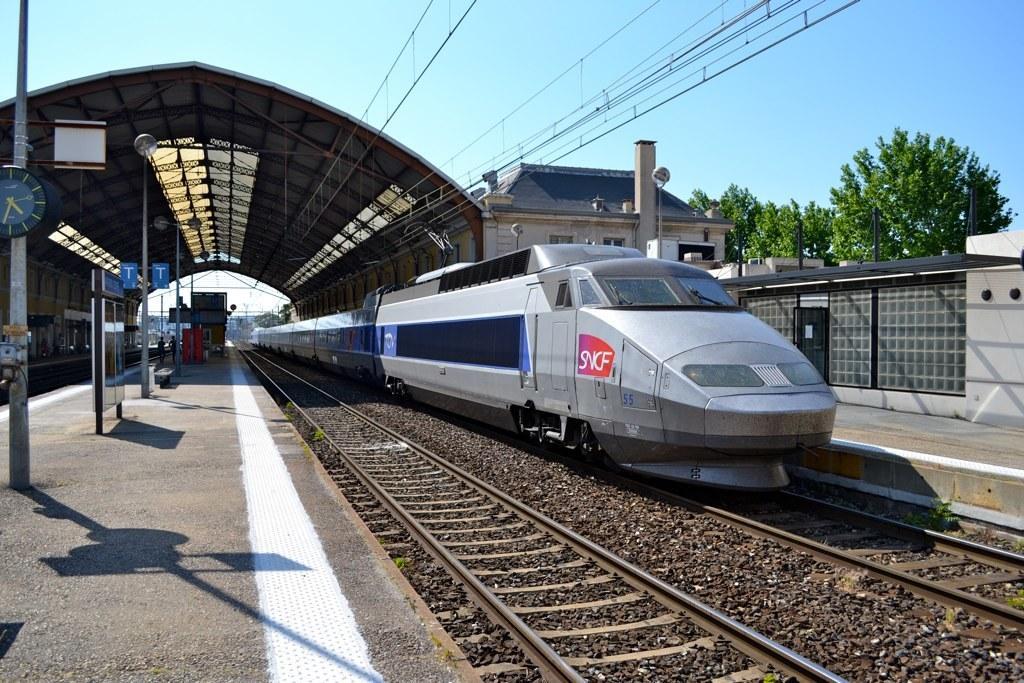What type of train do you see?
Your answer should be very brief. Sncf. What time is it, on the clock to the left?
Keep it short and to the point. 4:33. 